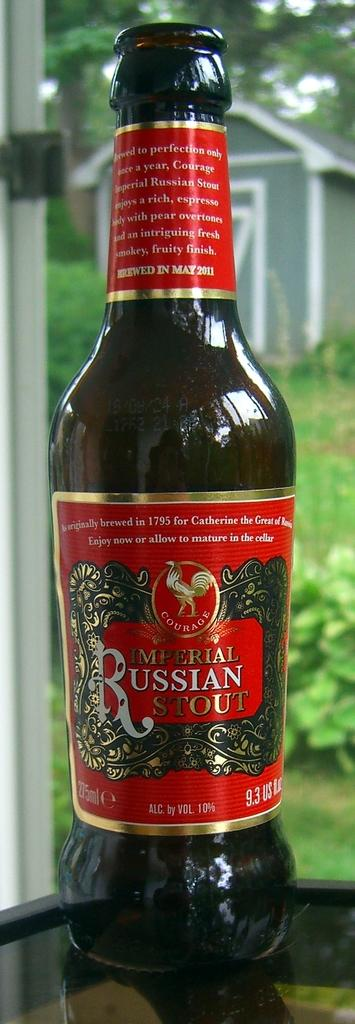<image>
Provide a brief description of the given image. A bottle of Imperial Russian Stout has a red label. 